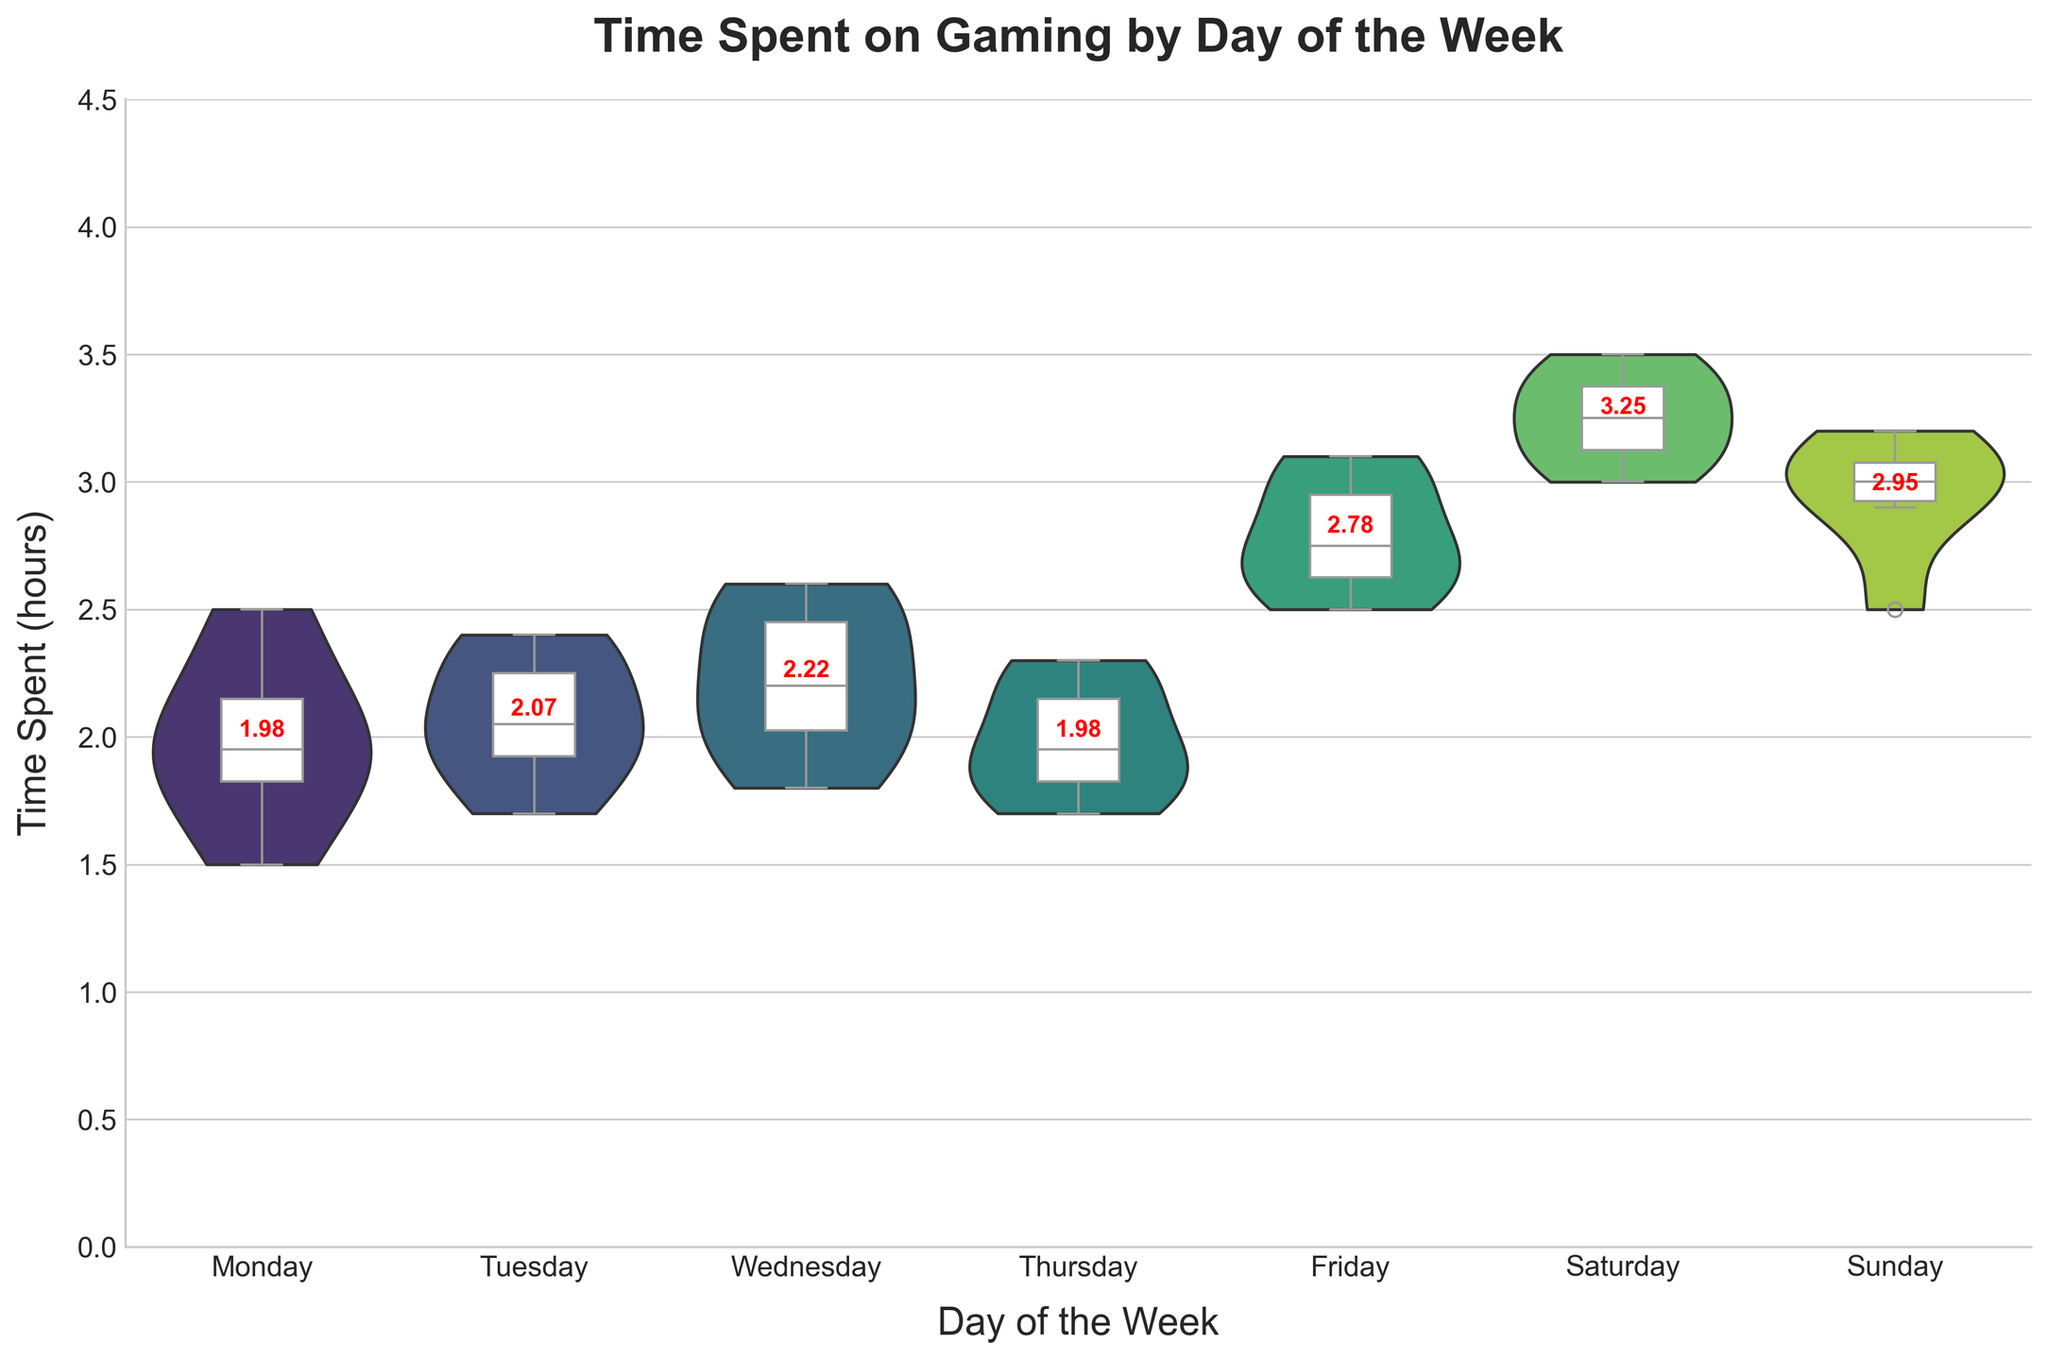What's the title of the figure? The title of the figure is usually displayed at the top of the chart in a larger font size. By glancing at the top portion of the plot, you can easily determine what it is titled.
Answer: Time Spent on Gaming by Day of the Week What are the labels of the X and Y axes? The X axis, located at the bottom of the chart, typically indicates the categories, while the Y axis on the side usually indicates the measured values. From the labels, one can tell what these axes are representing.
Answer: Day of the Week, Time Spent (hours) Which day has the highest mean gaming time? The mean gaming time for each day is shown with red text above the distributions in the plot. By comparing these numbers, we can determine which day has the highest mean. On Saturday, the mean gaming time is the highest at 3.25 hours.
Answer: Saturday What is the median gaming time on Friday? The median gaming time for Friday is shown within the box plot overlay on the violin chart. The median is the line inside the white box. Checking the position of this line for Friday, we can determine the median. It is approximately 2.75 hours.
Answer: 2.75 hours Compare the ranges of gaming time on Monday and Saturday. Which is greater? The range of time spent is indicated by the width of the violin plot and the whiskers of the box plot. The range is calculated as the difference between the maximum and minimum values. By comparing Monday and Saturday, we can see that Saturday's range is wider, extending from 3.5 to 2.5, while Monday ranges from about 1.5 to 2.5.
Answer: Saturday Which day shows the smallest variability in gaming time? Variability can be assessed by looking at the width of the violin plot and the length of the box and whiskers. A smaller width indicates less variability. By examining the plots, you can see that Monday has the smallest width, indicating the smallest variability.
Answer: Monday On which day is there the highest maximum gaming time? The highest maximum time is indicated by the upper whisker of the box plot. By examining each day, we notice that Saturday has the highest upper whisker at around 3.5 hours.
Answer: Saturday How does the distribution of gaming time on Sunday compare to Wednesday? Consider the shape, width, and spread of the violin plots. Sunday has a wider and higher spread indicating a similar, but slightly wider distribution and higher range compared to Wednesday. Both have means around 3 hours but Sunday’s wider plot suggests more variability towards higher values.
Answer: Sunday's distribution is wider with more variability towards higher values Which day has the most consistent gaming time around its mean? Consistency around the mean can be assessed by how tightly the data points are clustered around the mean within the violin plot and box plot. Wednesday shows the tightest clustering around its mean value of 2.22 hours, indicating the most consistent gaming time.
Answer: Wednesday 